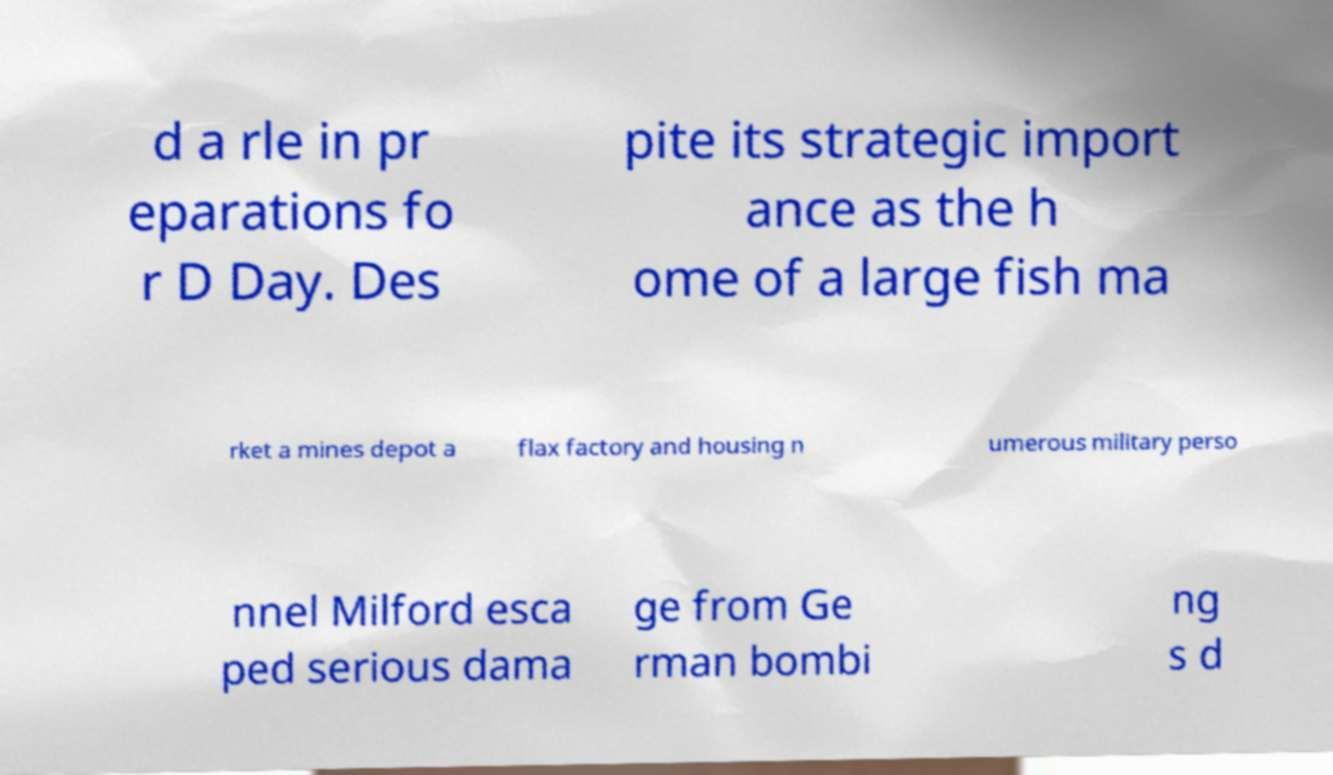There's text embedded in this image that I need extracted. Can you transcribe it verbatim? d a rle in pr eparations fo r D Day. Des pite its strategic import ance as the h ome of a large fish ma rket a mines depot a flax factory and housing n umerous military perso nnel Milford esca ped serious dama ge from Ge rman bombi ng s d 